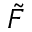Convert formula to latex. <formula><loc_0><loc_0><loc_500><loc_500>\tilde { F }</formula> 